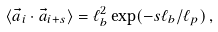<formula> <loc_0><loc_0><loc_500><loc_500>\langle \vec { a } _ { i } \cdot \vec { a } _ { i + s } \rangle = \ell _ { b } ^ { 2 } \exp ( - s \ell _ { b } / \ell _ { p } ) \, ,</formula> 